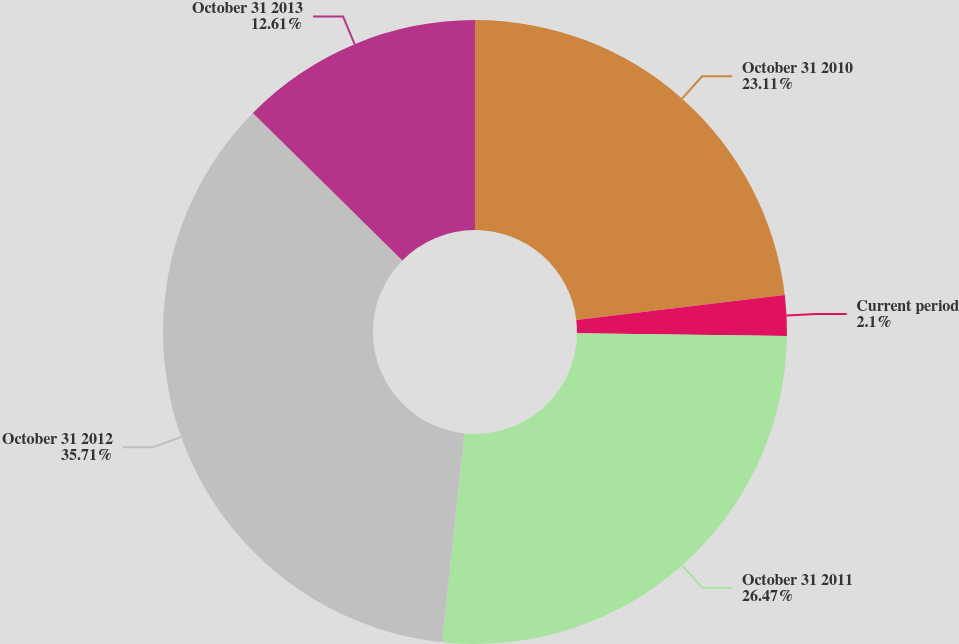Convert chart to OTSL. <chart><loc_0><loc_0><loc_500><loc_500><pie_chart><fcel>October 31 2010<fcel>Current period<fcel>October 31 2011<fcel>October 31 2012<fcel>October 31 2013<nl><fcel>23.11%<fcel>2.1%<fcel>26.47%<fcel>35.71%<fcel>12.61%<nl></chart> 